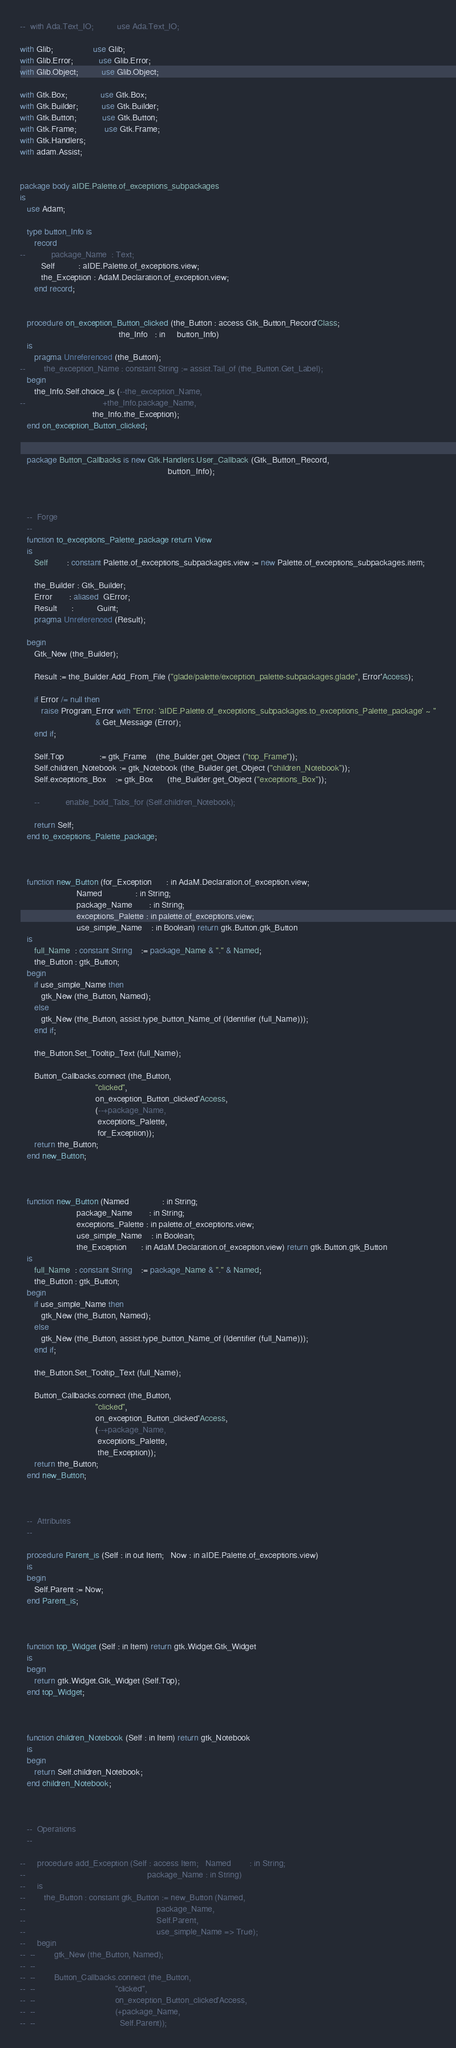Convert code to text. <code><loc_0><loc_0><loc_500><loc_500><_Ada_>--  with Ada.Text_IO;          use Ada.Text_IO;

with Glib;                 use Glib;
with Glib.Error;           use Glib.Error;
with Glib.Object;          use Glib.Object;

with Gtk.Box;              use Gtk.Box;
with Gtk.Builder;          use Gtk.Builder;
with Gtk.Button;           use Gtk.Button;
with Gtk.Frame;            use Gtk.Frame;
with Gtk.Handlers;
with adam.Assist;


package body aIDE.Palette.of_exceptions_subpackages
is
   use Adam;

   type button_Info is
      record
--           package_Name  : Text;
         Self          : aIDE.Palette.of_exceptions.view;
         the_Exception : AdaM.Declaration.of_exception.view;
      end record;


   procedure on_exception_Button_clicked (the_Button : access Gtk_Button_Record'Class;
                                          the_Info   : in     button_Info)
   is
      pragma Unreferenced (the_Button);
--        the_exception_Name : constant String := assist.Tail_of (the_Button.Get_Label);
   begin
      the_Info.Self.choice_is (--the_exception_Name,
--                                 +the_Info.package_Name,
                               the_Info.the_Exception);
   end on_exception_Button_clicked;


   package Button_Callbacks is new Gtk.Handlers.User_Callback (Gtk_Button_Record,
                                                               button_Info);



   --  Forge
   --
   function to_exceptions_Palette_package return View
   is
      Self        : constant Palette.of_exceptions_subpackages.view := new Palette.of_exceptions_subpackages.item;

      the_Builder : Gtk_Builder;
      Error       : aliased  GError;
      Result      :          Guint;
      pragma Unreferenced (Result);

   begin
      Gtk_New (the_Builder);

      Result := the_Builder.Add_From_File ("glade/palette/exception_palette-subpackages.glade", Error'Access);

      if Error /= null then
         raise Program_Error with "Error: 'aIDE.Palette.of_exceptions_subpackages.to_exceptions_Palette_package' ~ "
                                & Get_Message (Error);
      end if;

      Self.Top               := gtk_Frame    (the_Builder.get_Object ("top_Frame"));
      Self.children_Notebook := gtk_Notebook (the_Builder.get_Object ("children_Notebook"));
      Self.exceptions_Box    := gtk_Box      (the_Builder.get_Object ("exceptions_Box"));

      --           enable_bold_Tabs_for (Self.children_Notebook);

      return Self;
   end to_exceptions_Palette_package;



   function new_Button (for_Exception      : in AdaM.Declaration.of_exception.view;
                        Named              : in String;
                        package_Name       : in String;
                        exceptions_Palette : in palette.of_exceptions.view;
                        use_simple_Name    : in Boolean) return gtk.Button.gtk_Button
   is
      full_Name  : constant String    := package_Name & "." & Named;
      the_Button : gtk_Button;
   begin
      if use_simple_Name then
         gtk_New (the_Button, Named);
      else
         gtk_New (the_Button, assist.type_button_Name_of (Identifier (full_Name)));
      end if;

      the_Button.Set_Tooltip_Text (full_Name);

      Button_Callbacks.connect (the_Button,
                                "clicked",
                                on_exception_Button_clicked'Access,
                                (--+package_Name,
                                 exceptions_Palette,
                                 for_Exception));
      return the_Button;
   end new_Button;



   function new_Button (Named              : in String;
                        package_Name       : in String;
                        exceptions_Palette : in palette.of_exceptions.view;
                        use_simple_Name    : in Boolean;
                        the_Exception      : in AdaM.Declaration.of_exception.view) return gtk.Button.gtk_Button
   is
      full_Name  : constant String    := package_Name & "." & Named;
      the_Button : gtk_Button;
   begin
      if use_simple_Name then
         gtk_New (the_Button, Named);
      else
         gtk_New (the_Button, assist.type_button_Name_of (Identifier (full_Name)));
      end if;

      the_Button.Set_Tooltip_Text (full_Name);

      Button_Callbacks.connect (the_Button,
                                "clicked",
                                on_exception_Button_clicked'Access,
                                (--+package_Name,
                                 exceptions_Palette,
                                 the_Exception));
      return the_Button;
   end new_Button;



   --  Attributes
   --

   procedure Parent_is (Self : in out Item;   Now : in aIDE.Palette.of_exceptions.view)
   is
   begin
      Self.Parent := Now;
   end Parent_is;



   function top_Widget (Self : in Item) return gtk.Widget.Gtk_Widget
   is
   begin
      return gtk.Widget.Gtk_Widget (Self.Top);
   end top_Widget;



   function children_Notebook (Self : in Item) return gtk_Notebook
   is
   begin
      return Self.children_Notebook;
   end children_Notebook;



   --  Operations
   --

--     procedure add_Exception (Self : access Item;   Named        : in String;
--                                                    package_Name : in String)
--     is
--        the_Button : constant gtk_Button := new_Button (Named,
--                                                        package_Name,
--                                                        Self.Parent,
--                                                        use_simple_Name => True);
--     begin
--  --        gtk_New (the_Button, Named);
--  --
--  --        Button_Callbacks.connect (the_Button,
--  --                                  "clicked",
--  --                                  on_exception_Button_clicked'Access,
--  --                                  (+package_Name,
--  --                                    Self.Parent));</code> 